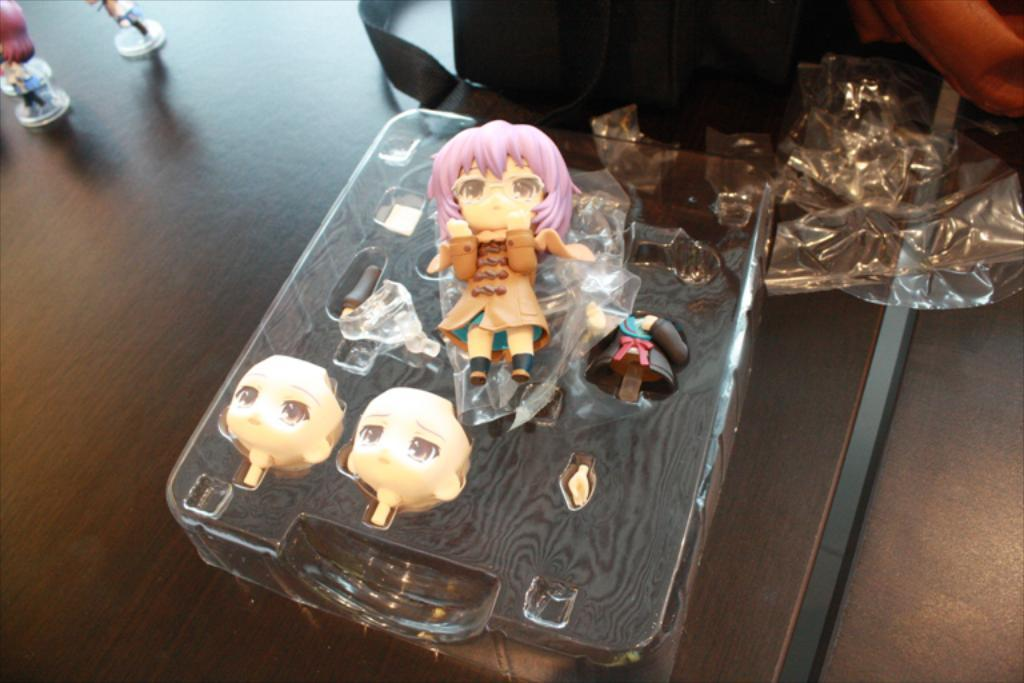What type of objects are in the image? There are dolls in the image. What is covering the objects in the image? There is a transparent cover in the image. What type of bag is present in the image? There is a bag in the image. On what surface are the objects placed? The objects are on a wooden table. What type of pet can be seen in the image? There is no pet present in the image. What nation is represented by the dolls in the image? The image does not depict any specific nation. What type of apparel are the dolls wearing in the image? The image does not show the dolls wearing any apparel. 